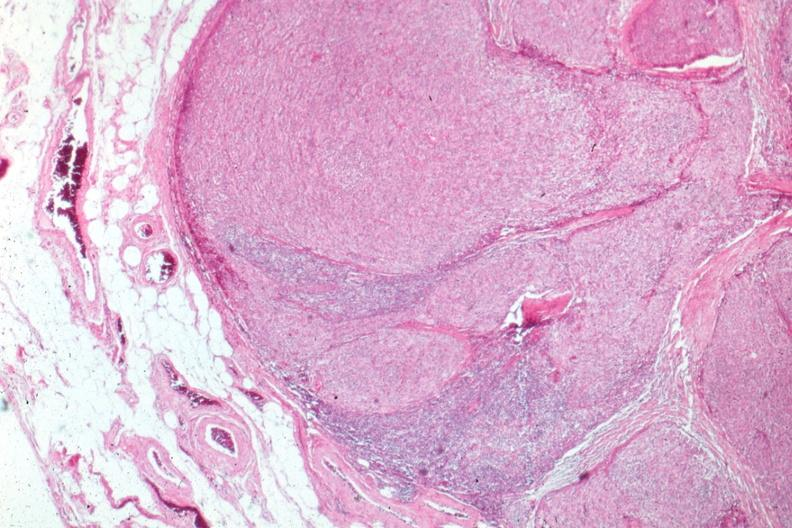what is present?
Answer the question using a single word or phrase. Hematologic 